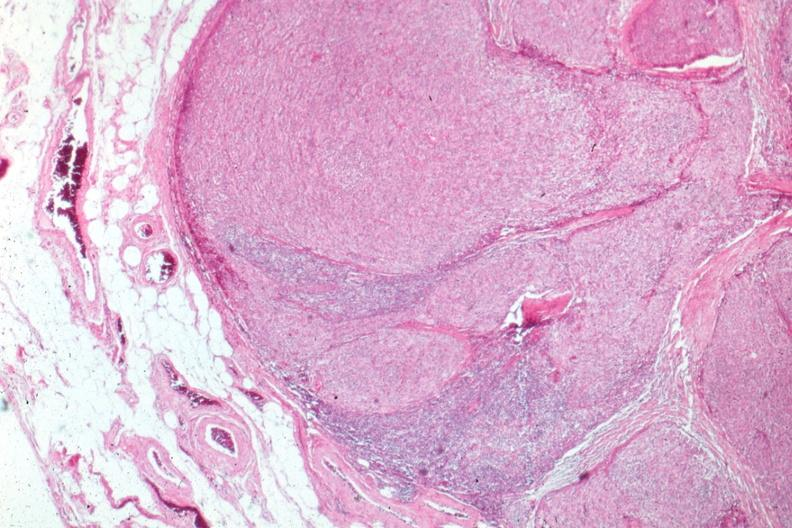what is present?
Answer the question using a single word or phrase. Hematologic 